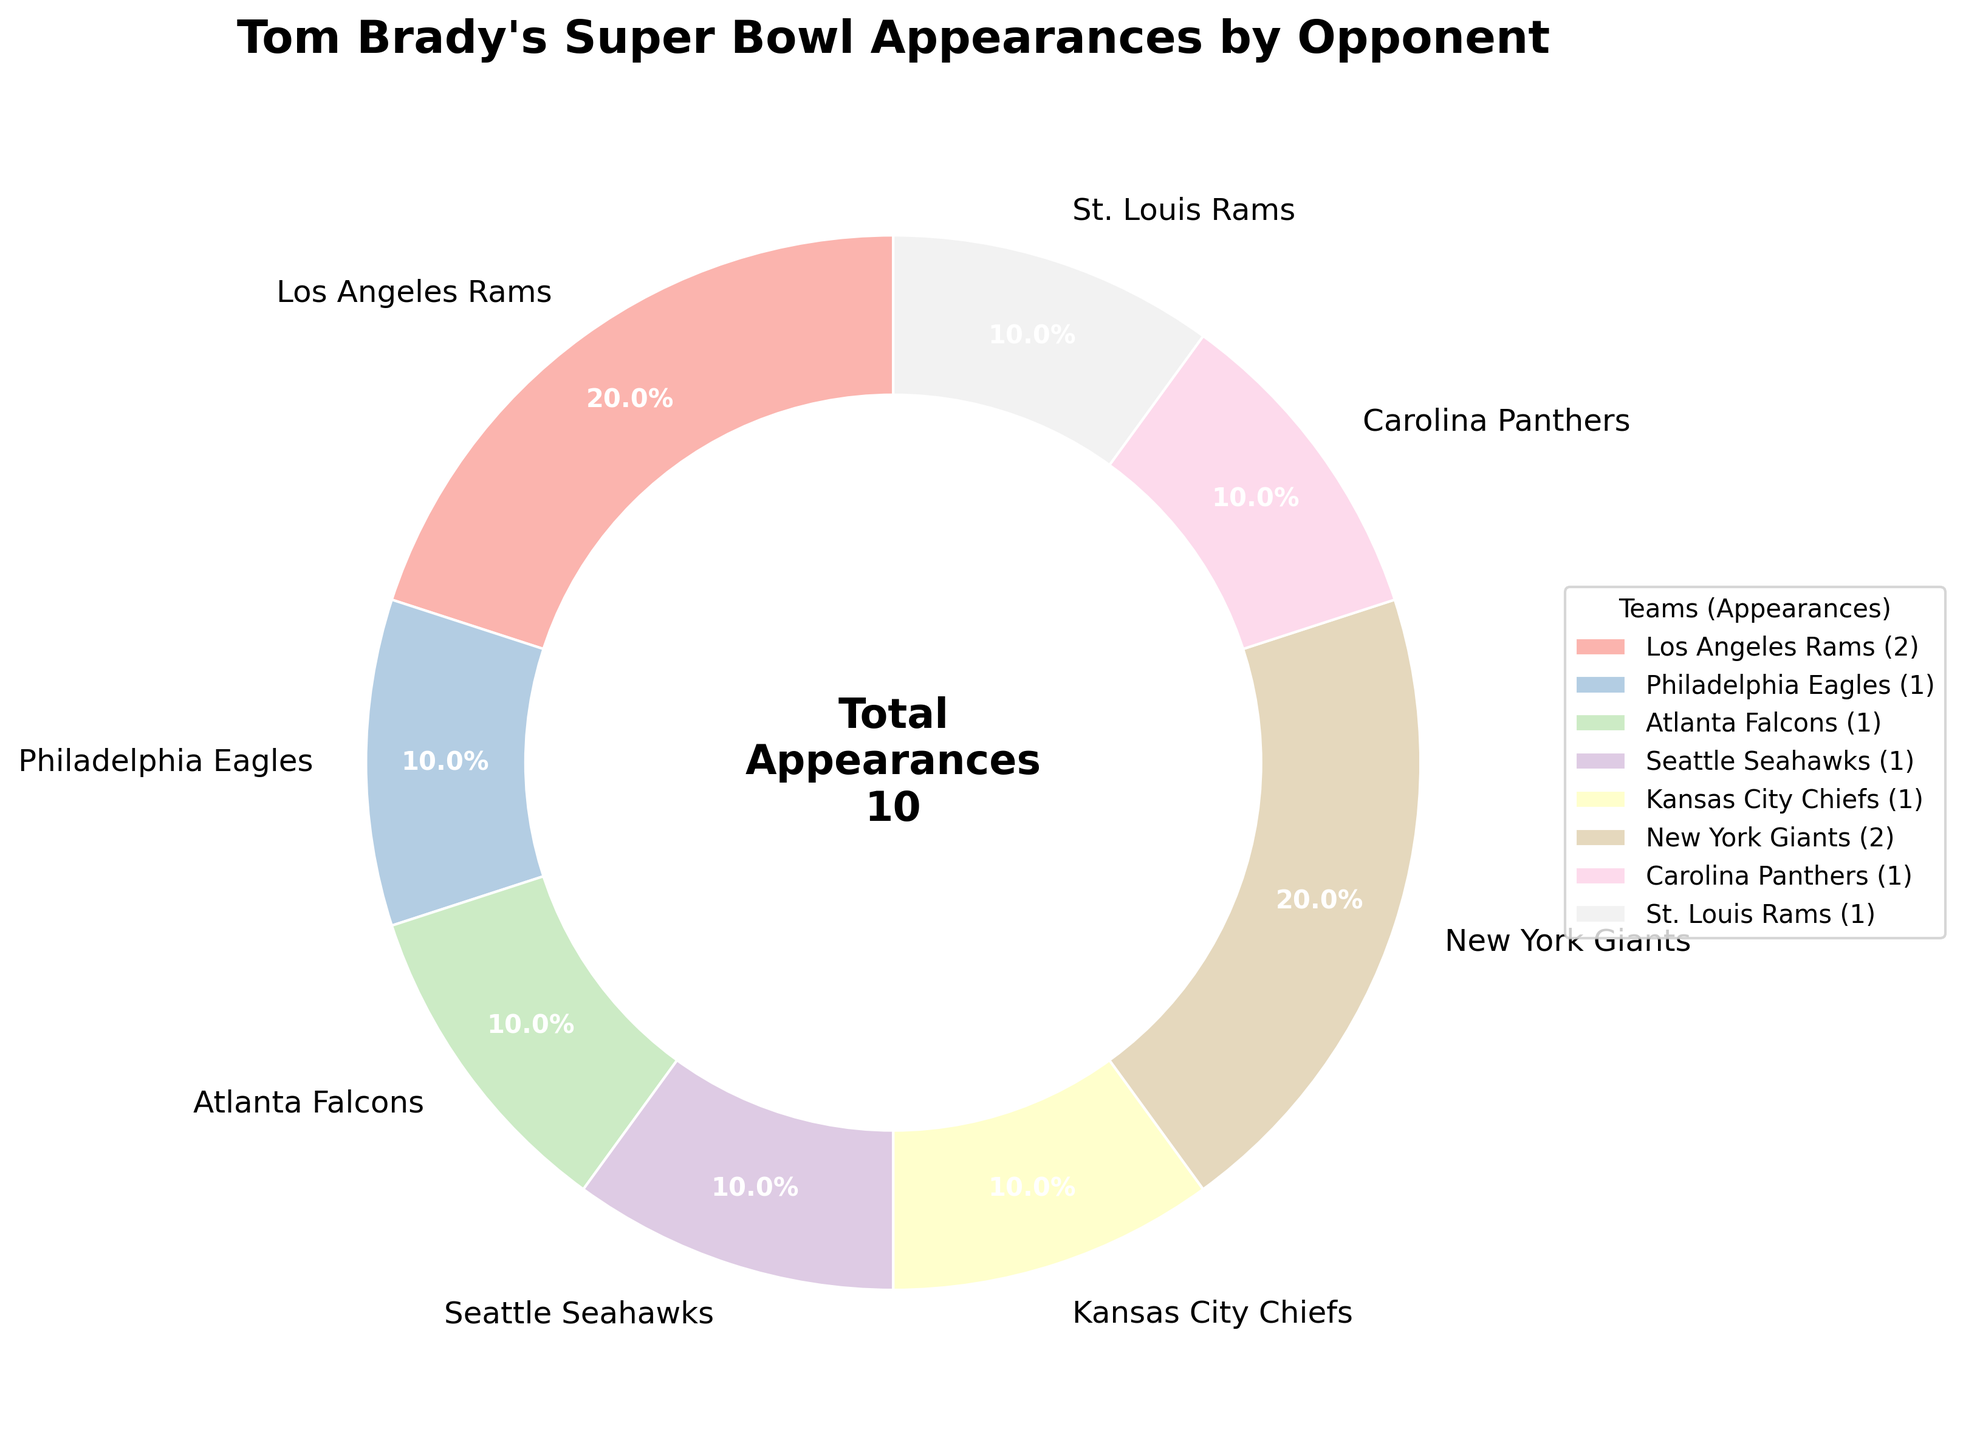What's the percentage of Super Bowl appearances against the Los Angeles Rams? The Los Angeles Rams appeared 2 times out of a total of 10 appearances. To find the percentage, use the formula (appearances by Los Angeles Rams / total appearances) * 100 = (2/10) * 100 = 20%.
Answer: 20% Which team has Tom Brady faced the most in the Super Bowl? By looking at the pie chart, the largest slices belong to the Los Angeles Rams and the New York Giants, each with 2 appearances.
Answer: Los Angeles Rams and New York Giants What proportion of Tom Brady's Super Bowl appearances were against NFC teams? Identify the teams from the NFC (Los Angeles Rams, Philadelphia Eagles, Atlanta Falcons, Seattle Seahawks, New York Giants, Carolina Panthers, St. Louis Rams) and sum their appearances: 2 + 1 + 1 + 1 + 2 + 1 + 1 = 9. Since the total appearances are 10, the proportion is 9/10.
Answer: 9/10 What's the combined percentage of appearances against the New York Giants and Philadelphia Eagles? Sum the appearances of the New York Giants (2) and Philadelphia Eagles (1): 2 + 1 = 3. Then calculate the percentage: (3/10) * 100 = 30%.
Answer: 30% How does the number of appearances against AFC teams compare to NFC teams? The AFC teams (Kansas City Chiefs) have 1 appearance, while the NFC teams have 9 appearances. Therefore, the number of appearances against NFC teams (9) is greater than against AFC teams (1).
Answer: NFC > AFC What is the median number of Super Bowl appearances by opponent? List the number of appearances in ascending order: 1, 1, 1, 1, 1, 1, 2, 2. Since there is an even number of teams, the median is the average of the 4th and 5th values: (1 + 1)/2 = 1.
Answer: 1 What's the smallest slice in the pie chart? All teams that appeared exactly once (Philadelphia Eagles, Atlanta Falcons, Seattle Seahawks, Kansas City Chiefs, Carolina Panthers, St. Louis Rams) share the smallest slice.
Answer: Eagles, Falcons, Seahawks, Chiefs, Panthers, Rams (St. Louis) Is there any team Tom Brady faced more than once, besides the Los Angeles Rams? By looking at the pie chart, the only other team he faced more than once is the New York Giants.
Answer: New York Giants How many teams has Tom Brady faced exactly once in the Super Bowl? Count the teams with 1 appearance: Philadelphia Eagles, Atlanta Falcons, Seattle Seahawks, Kansas City Chiefs, Carolina Panthers, and St. Louis Rams, totaling 6 teams.
Answer: 6 